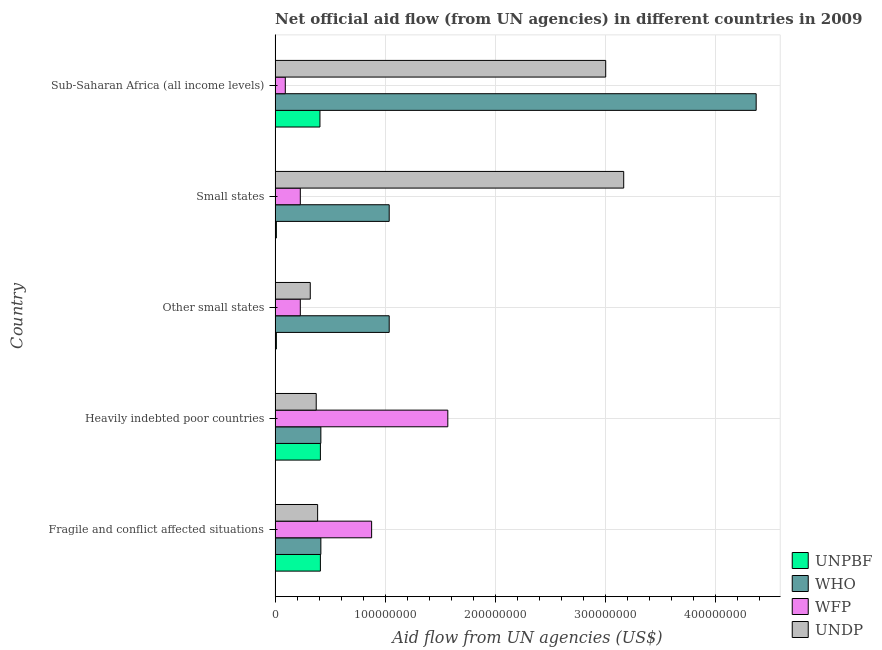Are the number of bars on each tick of the Y-axis equal?
Provide a succinct answer. Yes. How many bars are there on the 5th tick from the top?
Your answer should be compact. 4. What is the label of the 2nd group of bars from the top?
Make the answer very short. Small states. In how many cases, is the number of bars for a given country not equal to the number of legend labels?
Your answer should be very brief. 0. What is the amount of aid given by unpbf in Sub-Saharan Africa (all income levels)?
Make the answer very short. 4.07e+07. Across all countries, what is the maximum amount of aid given by who?
Keep it short and to the point. 4.37e+08. Across all countries, what is the minimum amount of aid given by unpbf?
Provide a succinct answer. 1.18e+06. In which country was the amount of aid given by who maximum?
Your answer should be very brief. Sub-Saharan Africa (all income levels). In which country was the amount of aid given by wfp minimum?
Keep it short and to the point. Sub-Saharan Africa (all income levels). What is the total amount of aid given by wfp in the graph?
Your answer should be compact. 3.00e+08. What is the difference between the amount of aid given by who in Small states and the amount of aid given by undp in Fragile and conflict affected situations?
Your answer should be compact. 6.50e+07. What is the average amount of aid given by unpbf per country?
Provide a short and direct response. 2.51e+07. What is the difference between the amount of aid given by undp and amount of aid given by wfp in Fragile and conflict affected situations?
Provide a short and direct response. -4.90e+07. In how many countries, is the amount of aid given by who greater than 260000000 US$?
Your answer should be compact. 1. What is the ratio of the amount of aid given by unpbf in Fragile and conflict affected situations to that in Other small states?
Your answer should be very brief. 34.86. Is the amount of aid given by wfp in Fragile and conflict affected situations less than that in Small states?
Keep it short and to the point. No. Is the difference between the amount of aid given by undp in Fragile and conflict affected situations and Heavily indebted poor countries greater than the difference between the amount of aid given by wfp in Fragile and conflict affected situations and Heavily indebted poor countries?
Your response must be concise. Yes. What is the difference between the highest and the second highest amount of aid given by wfp?
Offer a terse response. 6.92e+07. What is the difference between the highest and the lowest amount of aid given by undp?
Provide a succinct answer. 2.85e+08. In how many countries, is the amount of aid given by wfp greater than the average amount of aid given by wfp taken over all countries?
Provide a succinct answer. 2. Is it the case that in every country, the sum of the amount of aid given by who and amount of aid given by undp is greater than the sum of amount of aid given by unpbf and amount of aid given by wfp?
Ensure brevity in your answer.  No. What does the 2nd bar from the top in Other small states represents?
Provide a succinct answer. WFP. What does the 4th bar from the bottom in Fragile and conflict affected situations represents?
Make the answer very short. UNDP. How many bars are there?
Offer a terse response. 20. How many countries are there in the graph?
Make the answer very short. 5. Does the graph contain any zero values?
Provide a short and direct response. No. Does the graph contain grids?
Ensure brevity in your answer.  Yes. Where does the legend appear in the graph?
Offer a very short reply. Bottom right. How many legend labels are there?
Your answer should be compact. 4. How are the legend labels stacked?
Make the answer very short. Vertical. What is the title of the graph?
Offer a very short reply. Net official aid flow (from UN agencies) in different countries in 2009. What is the label or title of the X-axis?
Your response must be concise. Aid flow from UN agencies (US$). What is the label or title of the Y-axis?
Ensure brevity in your answer.  Country. What is the Aid flow from UN agencies (US$) of UNPBF in Fragile and conflict affected situations?
Your answer should be very brief. 4.11e+07. What is the Aid flow from UN agencies (US$) in WHO in Fragile and conflict affected situations?
Your answer should be very brief. 4.16e+07. What is the Aid flow from UN agencies (US$) of WFP in Fragile and conflict affected situations?
Ensure brevity in your answer.  8.77e+07. What is the Aid flow from UN agencies (US$) of UNDP in Fragile and conflict affected situations?
Ensure brevity in your answer.  3.86e+07. What is the Aid flow from UN agencies (US$) of UNPBF in Heavily indebted poor countries?
Your answer should be very brief. 4.11e+07. What is the Aid flow from UN agencies (US$) in WHO in Heavily indebted poor countries?
Offer a very short reply. 4.16e+07. What is the Aid flow from UN agencies (US$) of WFP in Heavily indebted poor countries?
Make the answer very short. 1.57e+08. What is the Aid flow from UN agencies (US$) in UNDP in Heavily indebted poor countries?
Provide a succinct answer. 3.74e+07. What is the Aid flow from UN agencies (US$) in UNPBF in Other small states?
Provide a succinct answer. 1.18e+06. What is the Aid flow from UN agencies (US$) of WHO in Other small states?
Offer a very short reply. 1.04e+08. What is the Aid flow from UN agencies (US$) in WFP in Other small states?
Offer a very short reply. 2.29e+07. What is the Aid flow from UN agencies (US$) in UNDP in Other small states?
Your response must be concise. 3.20e+07. What is the Aid flow from UN agencies (US$) of UNPBF in Small states?
Provide a succinct answer. 1.18e+06. What is the Aid flow from UN agencies (US$) in WHO in Small states?
Your answer should be compact. 1.04e+08. What is the Aid flow from UN agencies (US$) in WFP in Small states?
Your answer should be compact. 2.29e+07. What is the Aid flow from UN agencies (US$) of UNDP in Small states?
Provide a short and direct response. 3.17e+08. What is the Aid flow from UN agencies (US$) of UNPBF in Sub-Saharan Africa (all income levels)?
Provide a succinct answer. 4.07e+07. What is the Aid flow from UN agencies (US$) in WHO in Sub-Saharan Africa (all income levels)?
Your answer should be very brief. 4.37e+08. What is the Aid flow from UN agencies (US$) of WFP in Sub-Saharan Africa (all income levels)?
Your answer should be compact. 9.28e+06. What is the Aid flow from UN agencies (US$) of UNDP in Sub-Saharan Africa (all income levels)?
Give a very brief answer. 3.00e+08. Across all countries, what is the maximum Aid flow from UN agencies (US$) of UNPBF?
Your response must be concise. 4.11e+07. Across all countries, what is the maximum Aid flow from UN agencies (US$) in WHO?
Offer a terse response. 4.37e+08. Across all countries, what is the maximum Aid flow from UN agencies (US$) of WFP?
Provide a short and direct response. 1.57e+08. Across all countries, what is the maximum Aid flow from UN agencies (US$) of UNDP?
Give a very brief answer. 3.17e+08. Across all countries, what is the minimum Aid flow from UN agencies (US$) in UNPBF?
Your response must be concise. 1.18e+06. Across all countries, what is the minimum Aid flow from UN agencies (US$) in WHO?
Keep it short and to the point. 4.16e+07. Across all countries, what is the minimum Aid flow from UN agencies (US$) of WFP?
Make the answer very short. 9.28e+06. Across all countries, what is the minimum Aid flow from UN agencies (US$) in UNDP?
Give a very brief answer. 3.20e+07. What is the total Aid flow from UN agencies (US$) in UNPBF in the graph?
Offer a terse response. 1.25e+08. What is the total Aid flow from UN agencies (US$) in WHO in the graph?
Your response must be concise. 7.27e+08. What is the total Aid flow from UN agencies (US$) of WFP in the graph?
Ensure brevity in your answer.  3.00e+08. What is the total Aid flow from UN agencies (US$) in UNDP in the graph?
Keep it short and to the point. 7.25e+08. What is the difference between the Aid flow from UN agencies (US$) of UNPBF in Fragile and conflict affected situations and that in Heavily indebted poor countries?
Your response must be concise. 0. What is the difference between the Aid flow from UN agencies (US$) in WFP in Fragile and conflict affected situations and that in Heavily indebted poor countries?
Make the answer very short. -6.92e+07. What is the difference between the Aid flow from UN agencies (US$) in UNDP in Fragile and conflict affected situations and that in Heavily indebted poor countries?
Ensure brevity in your answer.  1.28e+06. What is the difference between the Aid flow from UN agencies (US$) of UNPBF in Fragile and conflict affected situations and that in Other small states?
Your response must be concise. 4.00e+07. What is the difference between the Aid flow from UN agencies (US$) in WHO in Fragile and conflict affected situations and that in Other small states?
Provide a short and direct response. -6.20e+07. What is the difference between the Aid flow from UN agencies (US$) in WFP in Fragile and conflict affected situations and that in Other small states?
Offer a terse response. 6.48e+07. What is the difference between the Aid flow from UN agencies (US$) of UNDP in Fragile and conflict affected situations and that in Other small states?
Offer a terse response. 6.68e+06. What is the difference between the Aid flow from UN agencies (US$) in UNPBF in Fragile and conflict affected situations and that in Small states?
Keep it short and to the point. 4.00e+07. What is the difference between the Aid flow from UN agencies (US$) in WHO in Fragile and conflict affected situations and that in Small states?
Ensure brevity in your answer.  -6.20e+07. What is the difference between the Aid flow from UN agencies (US$) in WFP in Fragile and conflict affected situations and that in Small states?
Ensure brevity in your answer.  6.48e+07. What is the difference between the Aid flow from UN agencies (US$) in UNDP in Fragile and conflict affected situations and that in Small states?
Give a very brief answer. -2.78e+08. What is the difference between the Aid flow from UN agencies (US$) in WHO in Fragile and conflict affected situations and that in Sub-Saharan Africa (all income levels)?
Keep it short and to the point. -3.95e+08. What is the difference between the Aid flow from UN agencies (US$) in WFP in Fragile and conflict affected situations and that in Sub-Saharan Africa (all income levels)?
Provide a short and direct response. 7.84e+07. What is the difference between the Aid flow from UN agencies (US$) in UNDP in Fragile and conflict affected situations and that in Sub-Saharan Africa (all income levels)?
Offer a very short reply. -2.62e+08. What is the difference between the Aid flow from UN agencies (US$) of UNPBF in Heavily indebted poor countries and that in Other small states?
Keep it short and to the point. 4.00e+07. What is the difference between the Aid flow from UN agencies (US$) of WHO in Heavily indebted poor countries and that in Other small states?
Your answer should be compact. -6.20e+07. What is the difference between the Aid flow from UN agencies (US$) in WFP in Heavily indebted poor countries and that in Other small states?
Your response must be concise. 1.34e+08. What is the difference between the Aid flow from UN agencies (US$) of UNDP in Heavily indebted poor countries and that in Other small states?
Offer a very short reply. 5.40e+06. What is the difference between the Aid flow from UN agencies (US$) of UNPBF in Heavily indebted poor countries and that in Small states?
Provide a succinct answer. 4.00e+07. What is the difference between the Aid flow from UN agencies (US$) of WHO in Heavily indebted poor countries and that in Small states?
Keep it short and to the point. -6.20e+07. What is the difference between the Aid flow from UN agencies (US$) in WFP in Heavily indebted poor countries and that in Small states?
Offer a terse response. 1.34e+08. What is the difference between the Aid flow from UN agencies (US$) of UNDP in Heavily indebted poor countries and that in Small states?
Provide a short and direct response. -2.79e+08. What is the difference between the Aid flow from UN agencies (US$) in WHO in Heavily indebted poor countries and that in Sub-Saharan Africa (all income levels)?
Offer a very short reply. -3.95e+08. What is the difference between the Aid flow from UN agencies (US$) of WFP in Heavily indebted poor countries and that in Sub-Saharan Africa (all income levels)?
Provide a short and direct response. 1.48e+08. What is the difference between the Aid flow from UN agencies (US$) of UNDP in Heavily indebted poor countries and that in Sub-Saharan Africa (all income levels)?
Offer a very short reply. -2.63e+08. What is the difference between the Aid flow from UN agencies (US$) in WHO in Other small states and that in Small states?
Your answer should be compact. 0. What is the difference between the Aid flow from UN agencies (US$) in WFP in Other small states and that in Small states?
Your answer should be very brief. 0. What is the difference between the Aid flow from UN agencies (US$) in UNDP in Other small states and that in Small states?
Keep it short and to the point. -2.85e+08. What is the difference between the Aid flow from UN agencies (US$) in UNPBF in Other small states and that in Sub-Saharan Africa (all income levels)?
Keep it short and to the point. -3.96e+07. What is the difference between the Aid flow from UN agencies (US$) of WHO in Other small states and that in Sub-Saharan Africa (all income levels)?
Your answer should be very brief. -3.33e+08. What is the difference between the Aid flow from UN agencies (US$) of WFP in Other small states and that in Sub-Saharan Africa (all income levels)?
Provide a short and direct response. 1.36e+07. What is the difference between the Aid flow from UN agencies (US$) of UNDP in Other small states and that in Sub-Saharan Africa (all income levels)?
Offer a very short reply. -2.68e+08. What is the difference between the Aid flow from UN agencies (US$) of UNPBF in Small states and that in Sub-Saharan Africa (all income levels)?
Your response must be concise. -3.96e+07. What is the difference between the Aid flow from UN agencies (US$) in WHO in Small states and that in Sub-Saharan Africa (all income levels)?
Provide a short and direct response. -3.33e+08. What is the difference between the Aid flow from UN agencies (US$) in WFP in Small states and that in Sub-Saharan Africa (all income levels)?
Your answer should be compact. 1.36e+07. What is the difference between the Aid flow from UN agencies (US$) of UNDP in Small states and that in Sub-Saharan Africa (all income levels)?
Your response must be concise. 1.63e+07. What is the difference between the Aid flow from UN agencies (US$) of UNPBF in Fragile and conflict affected situations and the Aid flow from UN agencies (US$) of WHO in Heavily indebted poor countries?
Offer a very short reply. -4.30e+05. What is the difference between the Aid flow from UN agencies (US$) in UNPBF in Fragile and conflict affected situations and the Aid flow from UN agencies (US$) in WFP in Heavily indebted poor countries?
Keep it short and to the point. -1.16e+08. What is the difference between the Aid flow from UN agencies (US$) of UNPBF in Fragile and conflict affected situations and the Aid flow from UN agencies (US$) of UNDP in Heavily indebted poor countries?
Your response must be concise. 3.79e+06. What is the difference between the Aid flow from UN agencies (US$) in WHO in Fragile and conflict affected situations and the Aid flow from UN agencies (US$) in WFP in Heavily indebted poor countries?
Keep it short and to the point. -1.15e+08. What is the difference between the Aid flow from UN agencies (US$) of WHO in Fragile and conflict affected situations and the Aid flow from UN agencies (US$) of UNDP in Heavily indebted poor countries?
Offer a very short reply. 4.22e+06. What is the difference between the Aid flow from UN agencies (US$) of WFP in Fragile and conflict affected situations and the Aid flow from UN agencies (US$) of UNDP in Heavily indebted poor countries?
Offer a terse response. 5.03e+07. What is the difference between the Aid flow from UN agencies (US$) in UNPBF in Fragile and conflict affected situations and the Aid flow from UN agencies (US$) in WHO in Other small states?
Keep it short and to the point. -6.25e+07. What is the difference between the Aid flow from UN agencies (US$) in UNPBF in Fragile and conflict affected situations and the Aid flow from UN agencies (US$) in WFP in Other small states?
Provide a succinct answer. 1.82e+07. What is the difference between the Aid flow from UN agencies (US$) in UNPBF in Fragile and conflict affected situations and the Aid flow from UN agencies (US$) in UNDP in Other small states?
Provide a short and direct response. 9.19e+06. What is the difference between the Aid flow from UN agencies (US$) of WHO in Fragile and conflict affected situations and the Aid flow from UN agencies (US$) of WFP in Other small states?
Your answer should be very brief. 1.87e+07. What is the difference between the Aid flow from UN agencies (US$) of WHO in Fragile and conflict affected situations and the Aid flow from UN agencies (US$) of UNDP in Other small states?
Your response must be concise. 9.62e+06. What is the difference between the Aid flow from UN agencies (US$) in WFP in Fragile and conflict affected situations and the Aid flow from UN agencies (US$) in UNDP in Other small states?
Your answer should be compact. 5.57e+07. What is the difference between the Aid flow from UN agencies (US$) in UNPBF in Fragile and conflict affected situations and the Aid flow from UN agencies (US$) in WHO in Small states?
Ensure brevity in your answer.  -6.25e+07. What is the difference between the Aid flow from UN agencies (US$) in UNPBF in Fragile and conflict affected situations and the Aid flow from UN agencies (US$) in WFP in Small states?
Your response must be concise. 1.82e+07. What is the difference between the Aid flow from UN agencies (US$) of UNPBF in Fragile and conflict affected situations and the Aid flow from UN agencies (US$) of UNDP in Small states?
Keep it short and to the point. -2.75e+08. What is the difference between the Aid flow from UN agencies (US$) in WHO in Fragile and conflict affected situations and the Aid flow from UN agencies (US$) in WFP in Small states?
Your answer should be very brief. 1.87e+07. What is the difference between the Aid flow from UN agencies (US$) in WHO in Fragile and conflict affected situations and the Aid flow from UN agencies (US$) in UNDP in Small states?
Give a very brief answer. -2.75e+08. What is the difference between the Aid flow from UN agencies (US$) in WFP in Fragile and conflict affected situations and the Aid flow from UN agencies (US$) in UNDP in Small states?
Ensure brevity in your answer.  -2.29e+08. What is the difference between the Aid flow from UN agencies (US$) in UNPBF in Fragile and conflict affected situations and the Aid flow from UN agencies (US$) in WHO in Sub-Saharan Africa (all income levels)?
Your response must be concise. -3.96e+08. What is the difference between the Aid flow from UN agencies (US$) of UNPBF in Fragile and conflict affected situations and the Aid flow from UN agencies (US$) of WFP in Sub-Saharan Africa (all income levels)?
Make the answer very short. 3.19e+07. What is the difference between the Aid flow from UN agencies (US$) in UNPBF in Fragile and conflict affected situations and the Aid flow from UN agencies (US$) in UNDP in Sub-Saharan Africa (all income levels)?
Ensure brevity in your answer.  -2.59e+08. What is the difference between the Aid flow from UN agencies (US$) in WHO in Fragile and conflict affected situations and the Aid flow from UN agencies (US$) in WFP in Sub-Saharan Africa (all income levels)?
Provide a short and direct response. 3.23e+07. What is the difference between the Aid flow from UN agencies (US$) in WHO in Fragile and conflict affected situations and the Aid flow from UN agencies (US$) in UNDP in Sub-Saharan Africa (all income levels)?
Ensure brevity in your answer.  -2.59e+08. What is the difference between the Aid flow from UN agencies (US$) of WFP in Fragile and conflict affected situations and the Aid flow from UN agencies (US$) of UNDP in Sub-Saharan Africa (all income levels)?
Provide a succinct answer. -2.13e+08. What is the difference between the Aid flow from UN agencies (US$) in UNPBF in Heavily indebted poor countries and the Aid flow from UN agencies (US$) in WHO in Other small states?
Offer a terse response. -6.25e+07. What is the difference between the Aid flow from UN agencies (US$) of UNPBF in Heavily indebted poor countries and the Aid flow from UN agencies (US$) of WFP in Other small states?
Your response must be concise. 1.82e+07. What is the difference between the Aid flow from UN agencies (US$) in UNPBF in Heavily indebted poor countries and the Aid flow from UN agencies (US$) in UNDP in Other small states?
Provide a short and direct response. 9.19e+06. What is the difference between the Aid flow from UN agencies (US$) of WHO in Heavily indebted poor countries and the Aid flow from UN agencies (US$) of WFP in Other small states?
Make the answer very short. 1.87e+07. What is the difference between the Aid flow from UN agencies (US$) in WHO in Heavily indebted poor countries and the Aid flow from UN agencies (US$) in UNDP in Other small states?
Offer a very short reply. 9.62e+06. What is the difference between the Aid flow from UN agencies (US$) in WFP in Heavily indebted poor countries and the Aid flow from UN agencies (US$) in UNDP in Other small states?
Provide a succinct answer. 1.25e+08. What is the difference between the Aid flow from UN agencies (US$) in UNPBF in Heavily indebted poor countries and the Aid flow from UN agencies (US$) in WHO in Small states?
Ensure brevity in your answer.  -6.25e+07. What is the difference between the Aid flow from UN agencies (US$) in UNPBF in Heavily indebted poor countries and the Aid flow from UN agencies (US$) in WFP in Small states?
Provide a succinct answer. 1.82e+07. What is the difference between the Aid flow from UN agencies (US$) of UNPBF in Heavily indebted poor countries and the Aid flow from UN agencies (US$) of UNDP in Small states?
Give a very brief answer. -2.75e+08. What is the difference between the Aid flow from UN agencies (US$) in WHO in Heavily indebted poor countries and the Aid flow from UN agencies (US$) in WFP in Small states?
Ensure brevity in your answer.  1.87e+07. What is the difference between the Aid flow from UN agencies (US$) of WHO in Heavily indebted poor countries and the Aid flow from UN agencies (US$) of UNDP in Small states?
Provide a short and direct response. -2.75e+08. What is the difference between the Aid flow from UN agencies (US$) of WFP in Heavily indebted poor countries and the Aid flow from UN agencies (US$) of UNDP in Small states?
Your answer should be very brief. -1.60e+08. What is the difference between the Aid flow from UN agencies (US$) of UNPBF in Heavily indebted poor countries and the Aid flow from UN agencies (US$) of WHO in Sub-Saharan Africa (all income levels)?
Offer a terse response. -3.96e+08. What is the difference between the Aid flow from UN agencies (US$) of UNPBF in Heavily indebted poor countries and the Aid flow from UN agencies (US$) of WFP in Sub-Saharan Africa (all income levels)?
Keep it short and to the point. 3.19e+07. What is the difference between the Aid flow from UN agencies (US$) in UNPBF in Heavily indebted poor countries and the Aid flow from UN agencies (US$) in UNDP in Sub-Saharan Africa (all income levels)?
Keep it short and to the point. -2.59e+08. What is the difference between the Aid flow from UN agencies (US$) in WHO in Heavily indebted poor countries and the Aid flow from UN agencies (US$) in WFP in Sub-Saharan Africa (all income levels)?
Keep it short and to the point. 3.23e+07. What is the difference between the Aid flow from UN agencies (US$) of WHO in Heavily indebted poor countries and the Aid flow from UN agencies (US$) of UNDP in Sub-Saharan Africa (all income levels)?
Your answer should be compact. -2.59e+08. What is the difference between the Aid flow from UN agencies (US$) in WFP in Heavily indebted poor countries and the Aid flow from UN agencies (US$) in UNDP in Sub-Saharan Africa (all income levels)?
Your answer should be very brief. -1.43e+08. What is the difference between the Aid flow from UN agencies (US$) in UNPBF in Other small states and the Aid flow from UN agencies (US$) in WHO in Small states?
Your response must be concise. -1.02e+08. What is the difference between the Aid flow from UN agencies (US$) of UNPBF in Other small states and the Aid flow from UN agencies (US$) of WFP in Small states?
Keep it short and to the point. -2.17e+07. What is the difference between the Aid flow from UN agencies (US$) of UNPBF in Other small states and the Aid flow from UN agencies (US$) of UNDP in Small states?
Keep it short and to the point. -3.15e+08. What is the difference between the Aid flow from UN agencies (US$) of WHO in Other small states and the Aid flow from UN agencies (US$) of WFP in Small states?
Provide a succinct answer. 8.07e+07. What is the difference between the Aid flow from UN agencies (US$) in WHO in Other small states and the Aid flow from UN agencies (US$) in UNDP in Small states?
Offer a terse response. -2.13e+08. What is the difference between the Aid flow from UN agencies (US$) of WFP in Other small states and the Aid flow from UN agencies (US$) of UNDP in Small states?
Offer a terse response. -2.94e+08. What is the difference between the Aid flow from UN agencies (US$) in UNPBF in Other small states and the Aid flow from UN agencies (US$) in WHO in Sub-Saharan Africa (all income levels)?
Give a very brief answer. -4.36e+08. What is the difference between the Aid flow from UN agencies (US$) in UNPBF in Other small states and the Aid flow from UN agencies (US$) in WFP in Sub-Saharan Africa (all income levels)?
Your answer should be very brief. -8.10e+06. What is the difference between the Aid flow from UN agencies (US$) in UNPBF in Other small states and the Aid flow from UN agencies (US$) in UNDP in Sub-Saharan Africa (all income levels)?
Keep it short and to the point. -2.99e+08. What is the difference between the Aid flow from UN agencies (US$) of WHO in Other small states and the Aid flow from UN agencies (US$) of WFP in Sub-Saharan Africa (all income levels)?
Ensure brevity in your answer.  9.43e+07. What is the difference between the Aid flow from UN agencies (US$) of WHO in Other small states and the Aid flow from UN agencies (US$) of UNDP in Sub-Saharan Africa (all income levels)?
Make the answer very short. -1.97e+08. What is the difference between the Aid flow from UN agencies (US$) of WFP in Other small states and the Aid flow from UN agencies (US$) of UNDP in Sub-Saharan Africa (all income levels)?
Make the answer very short. -2.77e+08. What is the difference between the Aid flow from UN agencies (US$) in UNPBF in Small states and the Aid flow from UN agencies (US$) in WHO in Sub-Saharan Africa (all income levels)?
Give a very brief answer. -4.36e+08. What is the difference between the Aid flow from UN agencies (US$) in UNPBF in Small states and the Aid flow from UN agencies (US$) in WFP in Sub-Saharan Africa (all income levels)?
Provide a short and direct response. -8.10e+06. What is the difference between the Aid flow from UN agencies (US$) of UNPBF in Small states and the Aid flow from UN agencies (US$) of UNDP in Sub-Saharan Africa (all income levels)?
Your answer should be compact. -2.99e+08. What is the difference between the Aid flow from UN agencies (US$) of WHO in Small states and the Aid flow from UN agencies (US$) of WFP in Sub-Saharan Africa (all income levels)?
Give a very brief answer. 9.43e+07. What is the difference between the Aid flow from UN agencies (US$) in WHO in Small states and the Aid flow from UN agencies (US$) in UNDP in Sub-Saharan Africa (all income levels)?
Give a very brief answer. -1.97e+08. What is the difference between the Aid flow from UN agencies (US$) of WFP in Small states and the Aid flow from UN agencies (US$) of UNDP in Sub-Saharan Africa (all income levels)?
Offer a very short reply. -2.77e+08. What is the average Aid flow from UN agencies (US$) in UNPBF per country?
Your answer should be compact. 2.51e+07. What is the average Aid flow from UN agencies (US$) in WHO per country?
Ensure brevity in your answer.  1.45e+08. What is the average Aid flow from UN agencies (US$) in WFP per country?
Your answer should be compact. 5.99e+07. What is the average Aid flow from UN agencies (US$) in UNDP per country?
Your answer should be compact. 1.45e+08. What is the difference between the Aid flow from UN agencies (US$) in UNPBF and Aid flow from UN agencies (US$) in WHO in Fragile and conflict affected situations?
Provide a succinct answer. -4.30e+05. What is the difference between the Aid flow from UN agencies (US$) in UNPBF and Aid flow from UN agencies (US$) in WFP in Fragile and conflict affected situations?
Keep it short and to the point. -4.65e+07. What is the difference between the Aid flow from UN agencies (US$) of UNPBF and Aid flow from UN agencies (US$) of UNDP in Fragile and conflict affected situations?
Your response must be concise. 2.51e+06. What is the difference between the Aid flow from UN agencies (US$) of WHO and Aid flow from UN agencies (US$) of WFP in Fragile and conflict affected situations?
Offer a terse response. -4.61e+07. What is the difference between the Aid flow from UN agencies (US$) in WHO and Aid flow from UN agencies (US$) in UNDP in Fragile and conflict affected situations?
Give a very brief answer. 2.94e+06. What is the difference between the Aid flow from UN agencies (US$) of WFP and Aid flow from UN agencies (US$) of UNDP in Fragile and conflict affected situations?
Provide a succinct answer. 4.90e+07. What is the difference between the Aid flow from UN agencies (US$) of UNPBF and Aid flow from UN agencies (US$) of WHO in Heavily indebted poor countries?
Give a very brief answer. -4.30e+05. What is the difference between the Aid flow from UN agencies (US$) of UNPBF and Aid flow from UN agencies (US$) of WFP in Heavily indebted poor countries?
Ensure brevity in your answer.  -1.16e+08. What is the difference between the Aid flow from UN agencies (US$) in UNPBF and Aid flow from UN agencies (US$) in UNDP in Heavily indebted poor countries?
Keep it short and to the point. 3.79e+06. What is the difference between the Aid flow from UN agencies (US$) of WHO and Aid flow from UN agencies (US$) of WFP in Heavily indebted poor countries?
Offer a terse response. -1.15e+08. What is the difference between the Aid flow from UN agencies (US$) in WHO and Aid flow from UN agencies (US$) in UNDP in Heavily indebted poor countries?
Your answer should be compact. 4.22e+06. What is the difference between the Aid flow from UN agencies (US$) in WFP and Aid flow from UN agencies (US$) in UNDP in Heavily indebted poor countries?
Make the answer very short. 1.19e+08. What is the difference between the Aid flow from UN agencies (US$) of UNPBF and Aid flow from UN agencies (US$) of WHO in Other small states?
Ensure brevity in your answer.  -1.02e+08. What is the difference between the Aid flow from UN agencies (US$) of UNPBF and Aid flow from UN agencies (US$) of WFP in Other small states?
Provide a succinct answer. -2.17e+07. What is the difference between the Aid flow from UN agencies (US$) of UNPBF and Aid flow from UN agencies (US$) of UNDP in Other small states?
Keep it short and to the point. -3.08e+07. What is the difference between the Aid flow from UN agencies (US$) in WHO and Aid flow from UN agencies (US$) in WFP in Other small states?
Give a very brief answer. 8.07e+07. What is the difference between the Aid flow from UN agencies (US$) in WHO and Aid flow from UN agencies (US$) in UNDP in Other small states?
Give a very brief answer. 7.17e+07. What is the difference between the Aid flow from UN agencies (US$) in WFP and Aid flow from UN agencies (US$) in UNDP in Other small states?
Keep it short and to the point. -9.04e+06. What is the difference between the Aid flow from UN agencies (US$) in UNPBF and Aid flow from UN agencies (US$) in WHO in Small states?
Make the answer very short. -1.02e+08. What is the difference between the Aid flow from UN agencies (US$) in UNPBF and Aid flow from UN agencies (US$) in WFP in Small states?
Your answer should be compact. -2.17e+07. What is the difference between the Aid flow from UN agencies (US$) of UNPBF and Aid flow from UN agencies (US$) of UNDP in Small states?
Ensure brevity in your answer.  -3.15e+08. What is the difference between the Aid flow from UN agencies (US$) in WHO and Aid flow from UN agencies (US$) in WFP in Small states?
Your answer should be very brief. 8.07e+07. What is the difference between the Aid flow from UN agencies (US$) in WHO and Aid flow from UN agencies (US$) in UNDP in Small states?
Your response must be concise. -2.13e+08. What is the difference between the Aid flow from UN agencies (US$) in WFP and Aid flow from UN agencies (US$) in UNDP in Small states?
Your answer should be very brief. -2.94e+08. What is the difference between the Aid flow from UN agencies (US$) in UNPBF and Aid flow from UN agencies (US$) in WHO in Sub-Saharan Africa (all income levels)?
Offer a terse response. -3.96e+08. What is the difference between the Aid flow from UN agencies (US$) of UNPBF and Aid flow from UN agencies (US$) of WFP in Sub-Saharan Africa (all income levels)?
Your answer should be compact. 3.15e+07. What is the difference between the Aid flow from UN agencies (US$) in UNPBF and Aid flow from UN agencies (US$) in UNDP in Sub-Saharan Africa (all income levels)?
Offer a terse response. -2.59e+08. What is the difference between the Aid flow from UN agencies (US$) in WHO and Aid flow from UN agencies (US$) in WFP in Sub-Saharan Africa (all income levels)?
Your answer should be very brief. 4.28e+08. What is the difference between the Aid flow from UN agencies (US$) in WHO and Aid flow from UN agencies (US$) in UNDP in Sub-Saharan Africa (all income levels)?
Provide a succinct answer. 1.37e+08. What is the difference between the Aid flow from UN agencies (US$) in WFP and Aid flow from UN agencies (US$) in UNDP in Sub-Saharan Africa (all income levels)?
Ensure brevity in your answer.  -2.91e+08. What is the ratio of the Aid flow from UN agencies (US$) in UNPBF in Fragile and conflict affected situations to that in Heavily indebted poor countries?
Offer a terse response. 1. What is the ratio of the Aid flow from UN agencies (US$) of WFP in Fragile and conflict affected situations to that in Heavily indebted poor countries?
Provide a short and direct response. 0.56. What is the ratio of the Aid flow from UN agencies (US$) of UNDP in Fragile and conflict affected situations to that in Heavily indebted poor countries?
Offer a terse response. 1.03. What is the ratio of the Aid flow from UN agencies (US$) in UNPBF in Fragile and conflict affected situations to that in Other small states?
Your response must be concise. 34.86. What is the ratio of the Aid flow from UN agencies (US$) in WHO in Fragile and conflict affected situations to that in Other small states?
Give a very brief answer. 0.4. What is the ratio of the Aid flow from UN agencies (US$) in WFP in Fragile and conflict affected situations to that in Other small states?
Provide a short and direct response. 3.83. What is the ratio of the Aid flow from UN agencies (US$) in UNDP in Fragile and conflict affected situations to that in Other small states?
Give a very brief answer. 1.21. What is the ratio of the Aid flow from UN agencies (US$) in UNPBF in Fragile and conflict affected situations to that in Small states?
Make the answer very short. 34.86. What is the ratio of the Aid flow from UN agencies (US$) in WHO in Fragile and conflict affected situations to that in Small states?
Keep it short and to the point. 0.4. What is the ratio of the Aid flow from UN agencies (US$) in WFP in Fragile and conflict affected situations to that in Small states?
Offer a terse response. 3.83. What is the ratio of the Aid flow from UN agencies (US$) in UNDP in Fragile and conflict affected situations to that in Small states?
Your answer should be very brief. 0.12. What is the ratio of the Aid flow from UN agencies (US$) of UNPBF in Fragile and conflict affected situations to that in Sub-Saharan Africa (all income levels)?
Provide a succinct answer. 1.01. What is the ratio of the Aid flow from UN agencies (US$) of WHO in Fragile and conflict affected situations to that in Sub-Saharan Africa (all income levels)?
Provide a succinct answer. 0.1. What is the ratio of the Aid flow from UN agencies (US$) in WFP in Fragile and conflict affected situations to that in Sub-Saharan Africa (all income levels)?
Your answer should be compact. 9.45. What is the ratio of the Aid flow from UN agencies (US$) of UNDP in Fragile and conflict affected situations to that in Sub-Saharan Africa (all income levels)?
Give a very brief answer. 0.13. What is the ratio of the Aid flow from UN agencies (US$) in UNPBF in Heavily indebted poor countries to that in Other small states?
Your answer should be very brief. 34.86. What is the ratio of the Aid flow from UN agencies (US$) of WHO in Heavily indebted poor countries to that in Other small states?
Offer a very short reply. 0.4. What is the ratio of the Aid flow from UN agencies (US$) in WFP in Heavily indebted poor countries to that in Other small states?
Ensure brevity in your answer.  6.85. What is the ratio of the Aid flow from UN agencies (US$) of UNDP in Heavily indebted poor countries to that in Other small states?
Provide a short and direct response. 1.17. What is the ratio of the Aid flow from UN agencies (US$) in UNPBF in Heavily indebted poor countries to that in Small states?
Offer a terse response. 34.86. What is the ratio of the Aid flow from UN agencies (US$) in WHO in Heavily indebted poor countries to that in Small states?
Give a very brief answer. 0.4. What is the ratio of the Aid flow from UN agencies (US$) in WFP in Heavily indebted poor countries to that in Small states?
Give a very brief answer. 6.85. What is the ratio of the Aid flow from UN agencies (US$) in UNDP in Heavily indebted poor countries to that in Small states?
Your response must be concise. 0.12. What is the ratio of the Aid flow from UN agencies (US$) in UNPBF in Heavily indebted poor countries to that in Sub-Saharan Africa (all income levels)?
Give a very brief answer. 1.01. What is the ratio of the Aid flow from UN agencies (US$) of WHO in Heavily indebted poor countries to that in Sub-Saharan Africa (all income levels)?
Give a very brief answer. 0.1. What is the ratio of the Aid flow from UN agencies (US$) in WFP in Heavily indebted poor countries to that in Sub-Saharan Africa (all income levels)?
Your answer should be very brief. 16.9. What is the ratio of the Aid flow from UN agencies (US$) of UNDP in Heavily indebted poor countries to that in Sub-Saharan Africa (all income levels)?
Your answer should be compact. 0.12. What is the ratio of the Aid flow from UN agencies (US$) of UNPBF in Other small states to that in Small states?
Keep it short and to the point. 1. What is the ratio of the Aid flow from UN agencies (US$) in UNDP in Other small states to that in Small states?
Your response must be concise. 0.1. What is the ratio of the Aid flow from UN agencies (US$) of UNPBF in Other small states to that in Sub-Saharan Africa (all income levels)?
Provide a short and direct response. 0.03. What is the ratio of the Aid flow from UN agencies (US$) of WHO in Other small states to that in Sub-Saharan Africa (all income levels)?
Your answer should be compact. 0.24. What is the ratio of the Aid flow from UN agencies (US$) in WFP in Other small states to that in Sub-Saharan Africa (all income levels)?
Offer a terse response. 2.47. What is the ratio of the Aid flow from UN agencies (US$) of UNDP in Other small states to that in Sub-Saharan Africa (all income levels)?
Provide a short and direct response. 0.11. What is the ratio of the Aid flow from UN agencies (US$) in UNPBF in Small states to that in Sub-Saharan Africa (all income levels)?
Your answer should be very brief. 0.03. What is the ratio of the Aid flow from UN agencies (US$) in WHO in Small states to that in Sub-Saharan Africa (all income levels)?
Ensure brevity in your answer.  0.24. What is the ratio of the Aid flow from UN agencies (US$) of WFP in Small states to that in Sub-Saharan Africa (all income levels)?
Your answer should be very brief. 2.47. What is the ratio of the Aid flow from UN agencies (US$) of UNDP in Small states to that in Sub-Saharan Africa (all income levels)?
Your response must be concise. 1.05. What is the difference between the highest and the second highest Aid flow from UN agencies (US$) of UNPBF?
Offer a very short reply. 0. What is the difference between the highest and the second highest Aid flow from UN agencies (US$) in WHO?
Ensure brevity in your answer.  3.33e+08. What is the difference between the highest and the second highest Aid flow from UN agencies (US$) in WFP?
Offer a terse response. 6.92e+07. What is the difference between the highest and the second highest Aid flow from UN agencies (US$) of UNDP?
Your answer should be very brief. 1.63e+07. What is the difference between the highest and the lowest Aid flow from UN agencies (US$) of UNPBF?
Make the answer very short. 4.00e+07. What is the difference between the highest and the lowest Aid flow from UN agencies (US$) of WHO?
Your answer should be very brief. 3.95e+08. What is the difference between the highest and the lowest Aid flow from UN agencies (US$) in WFP?
Make the answer very short. 1.48e+08. What is the difference between the highest and the lowest Aid flow from UN agencies (US$) in UNDP?
Offer a very short reply. 2.85e+08. 